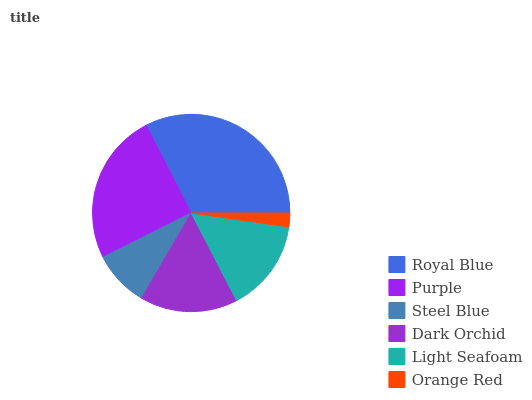Is Orange Red the minimum?
Answer yes or no. Yes. Is Royal Blue the maximum?
Answer yes or no. Yes. Is Purple the minimum?
Answer yes or no. No. Is Purple the maximum?
Answer yes or no. No. Is Royal Blue greater than Purple?
Answer yes or no. Yes. Is Purple less than Royal Blue?
Answer yes or no. Yes. Is Purple greater than Royal Blue?
Answer yes or no. No. Is Royal Blue less than Purple?
Answer yes or no. No. Is Dark Orchid the high median?
Answer yes or no. Yes. Is Light Seafoam the low median?
Answer yes or no. Yes. Is Royal Blue the high median?
Answer yes or no. No. Is Dark Orchid the low median?
Answer yes or no. No. 